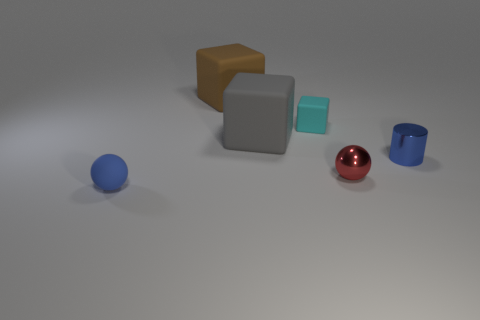How do the textures of the objects differ from one another? The objects in the image possess varying textures: the blue, brown, and gray objects have a matte, rubber-like finish, diffusing light softly. On the other hand, the red sphere has a polished, reflective surface that creates a bright highlight and distinct mirroring of the environment, indicative of a metallic or glass material. 